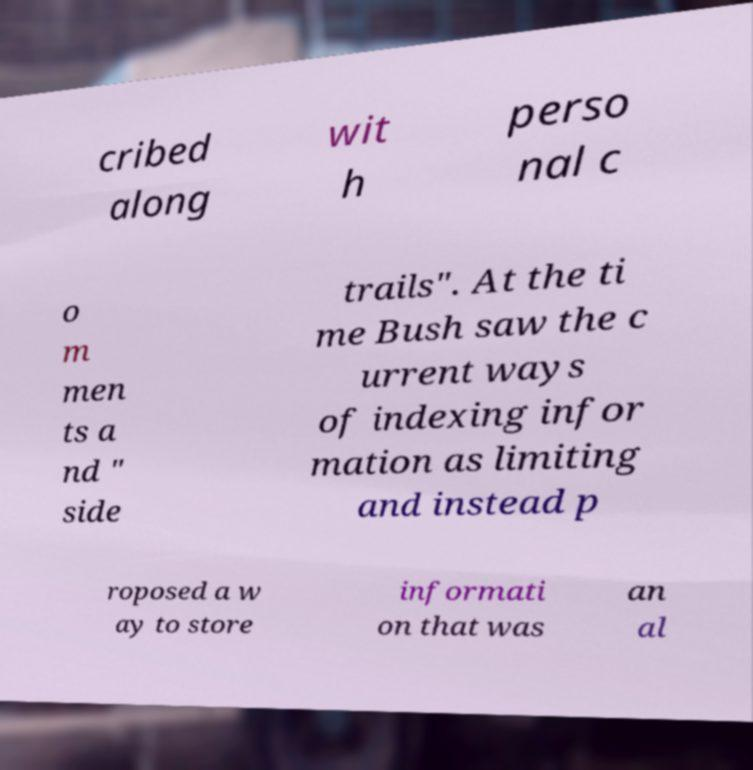For documentation purposes, I need the text within this image transcribed. Could you provide that? cribed along wit h perso nal c o m men ts a nd " side trails". At the ti me Bush saw the c urrent ways of indexing infor mation as limiting and instead p roposed a w ay to store informati on that was an al 